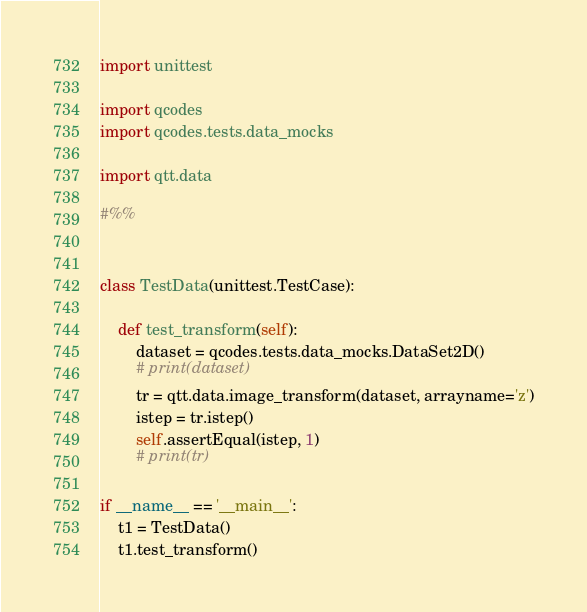Convert code to text. <code><loc_0><loc_0><loc_500><loc_500><_Python_>import unittest 

import qcodes
import qcodes.tests.data_mocks

import qtt.data

#%%


class TestData(unittest.TestCase):

    def test_transform(self):
        dataset = qcodes.tests.data_mocks.DataSet2D()
        # print(dataset)
        tr = qtt.data.image_transform(dataset, arrayname='z')
        istep = tr.istep()
        self.assertEqual(istep, 1)
        # print(tr)

if __name__ == '__main__':
    t1 = TestData()
    t1.test_transform()
</code> 